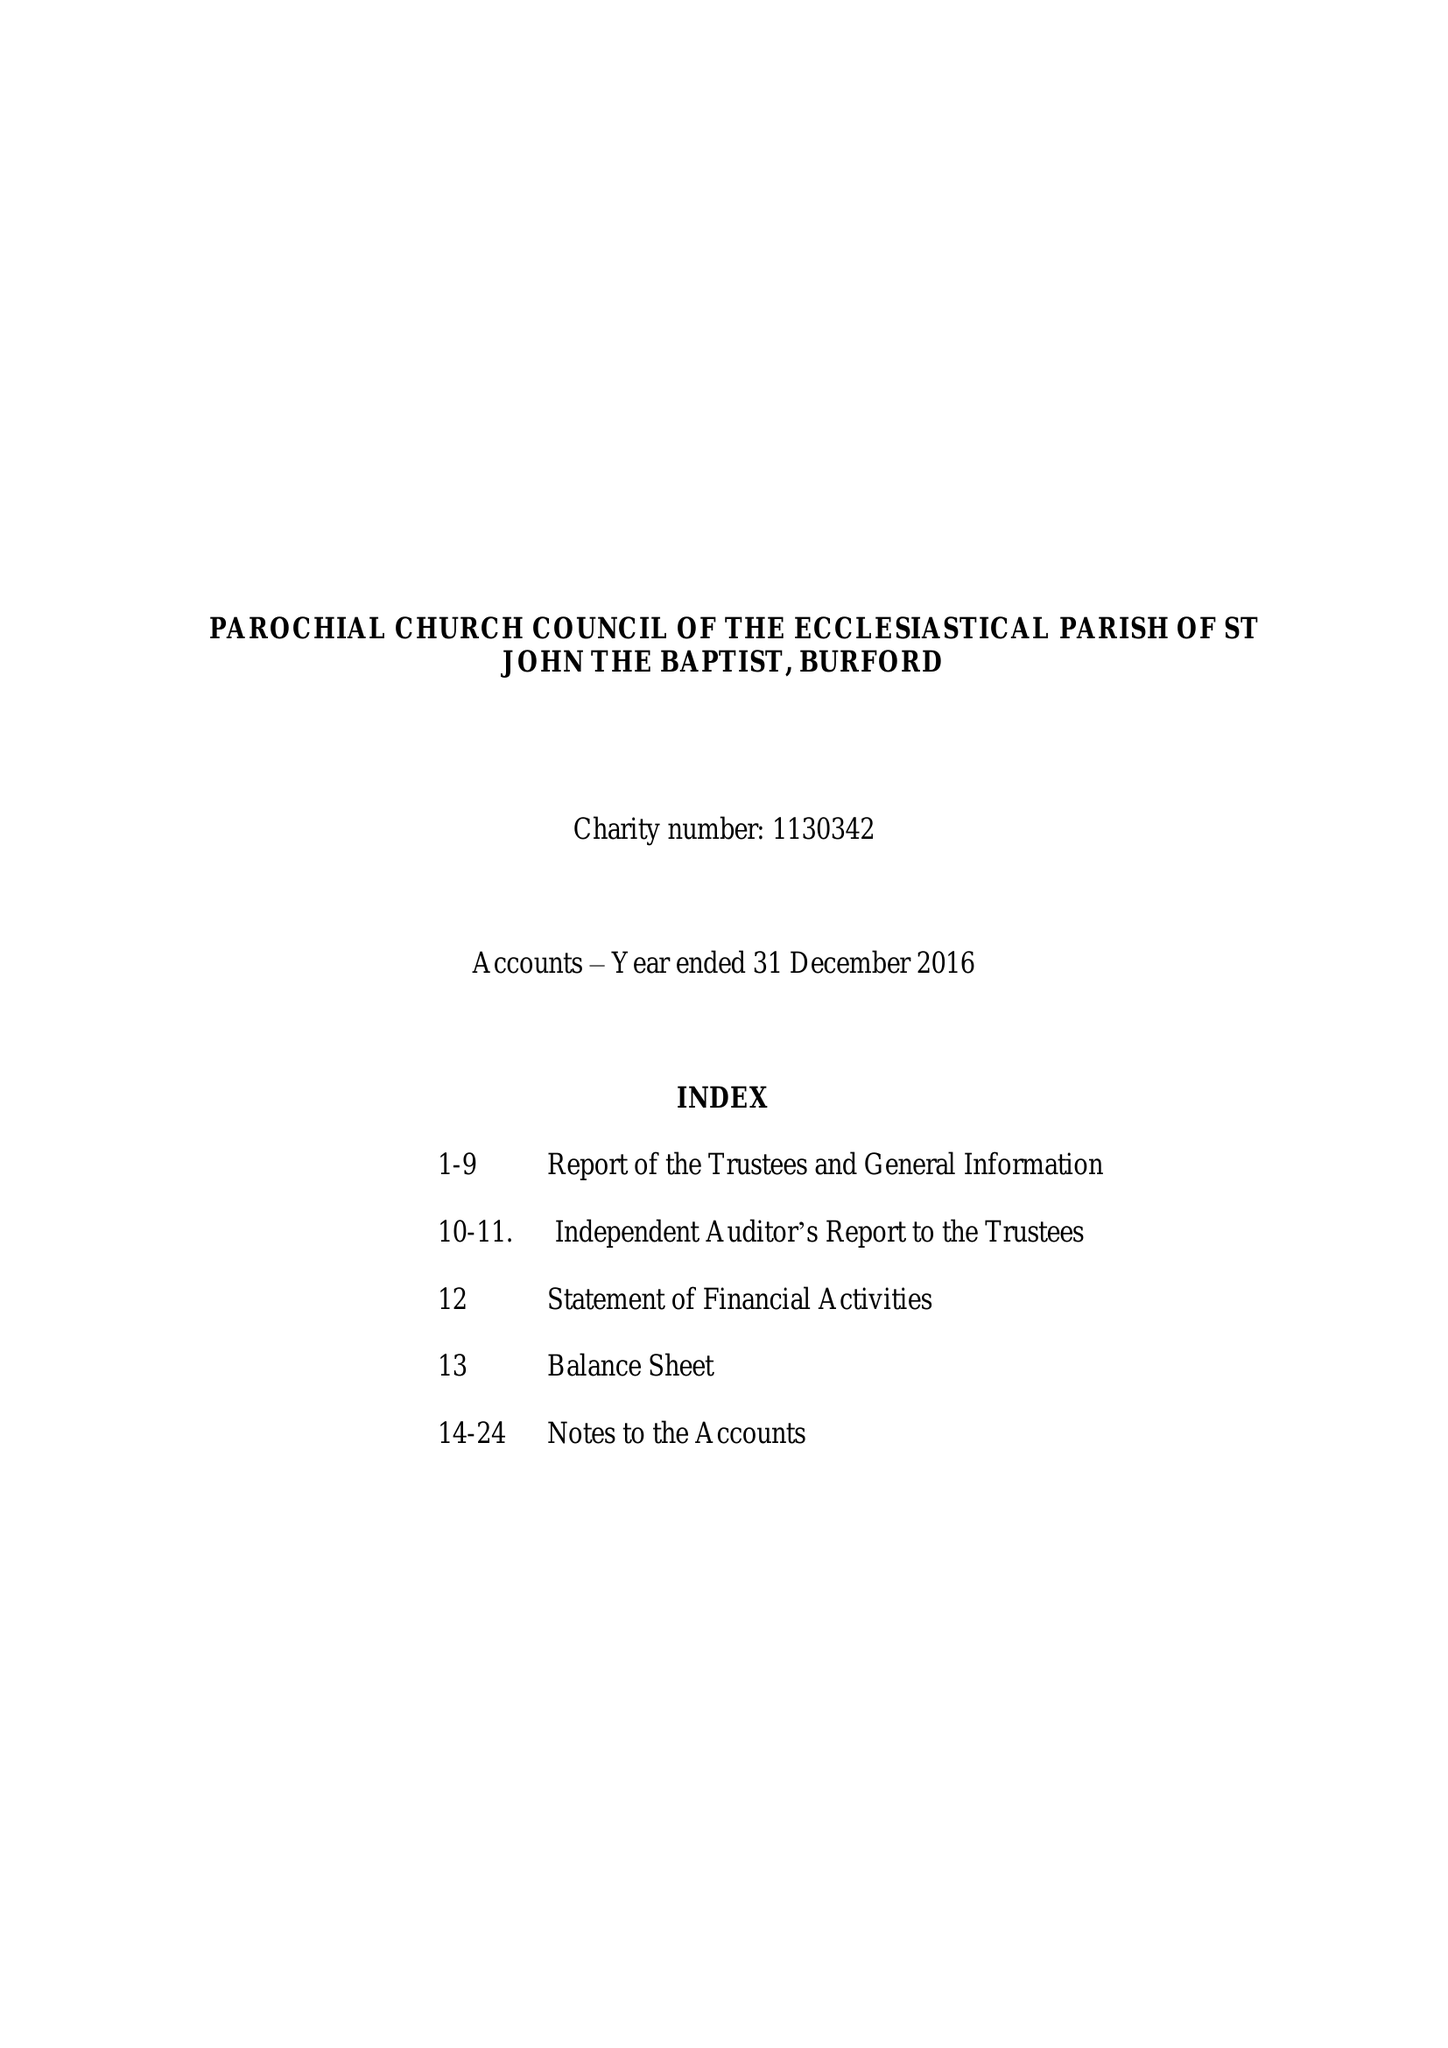What is the value for the address__street_line?
Answer the question using a single word or phrase. CHURCH GREEN 